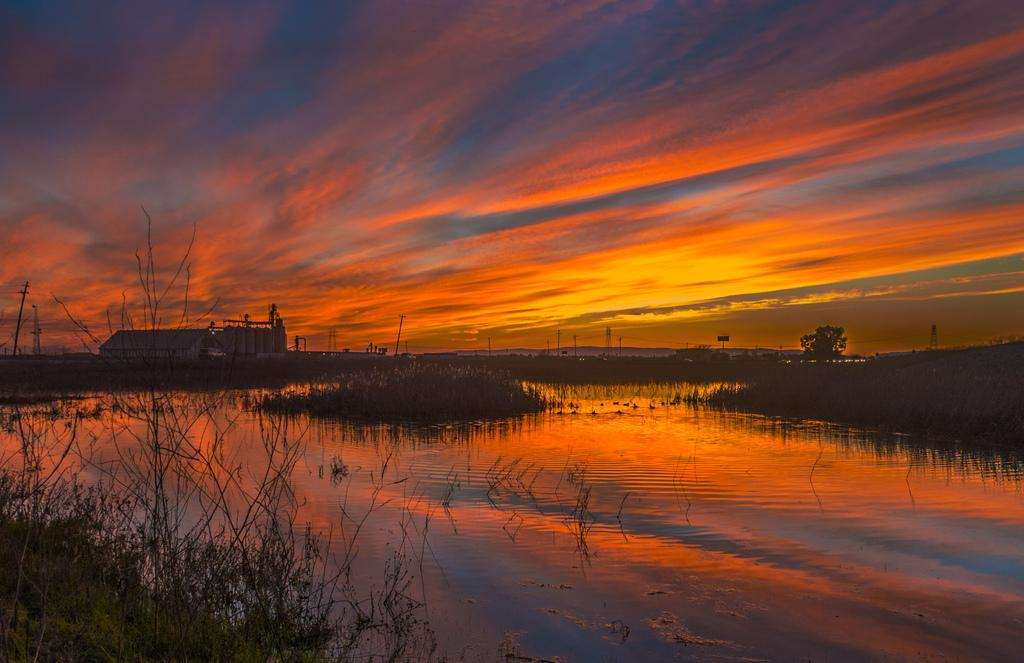What type of structure is visible in the image? There is a house in the image. What other natural elements can be seen in the image? There are plants, a large water body, trees, and the sky visible in the image. Are there any man-made structures besides the house? Yes, there are poles and towers in the image. How would you describe the weather based on the image? The sky appears cloudy in the image, suggesting a potentially overcast or rainy day. What type of scent can be detected from the cemetery in the image? There is no cemetery present in the image, so it is not possible to detect any scent. 